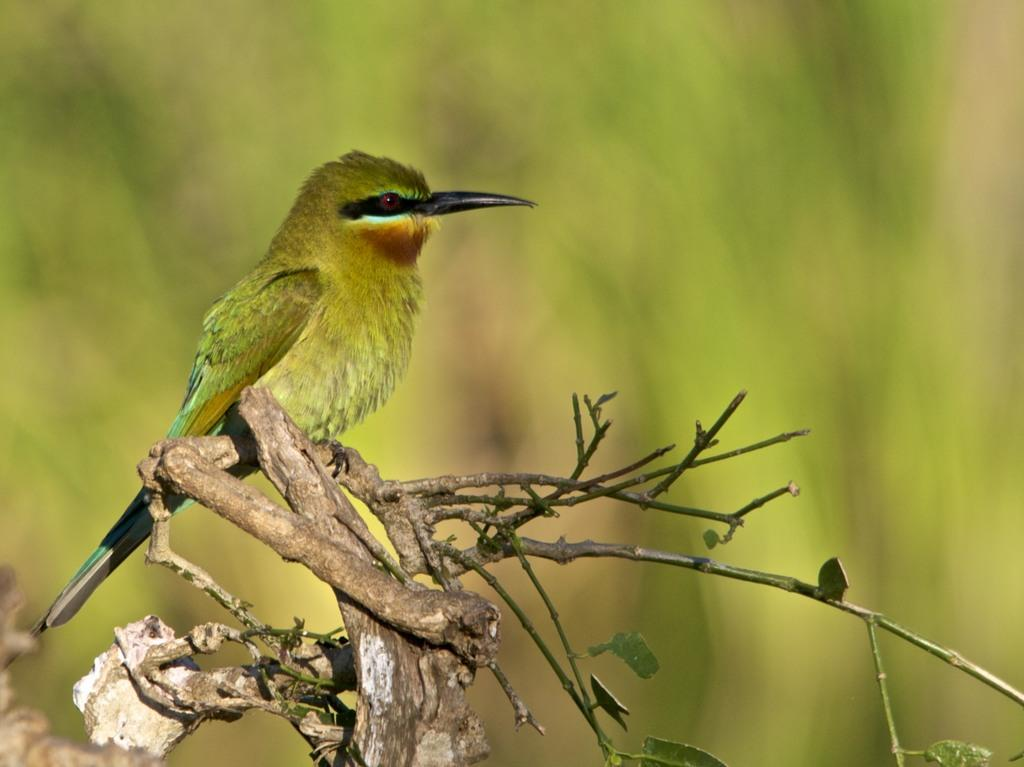What type of animal can be seen in the image? There is a bird in the image. Where is the bird located in the image? The bird is present on the stem of a plant. Can you describe the background of the image? The background of the image is blurry. What invention is the bird using to fly in the image? There is no invention present in the image, and the bird is not flying. What type of yoke is the bird holding in the image? There is no yoke present in the image. 